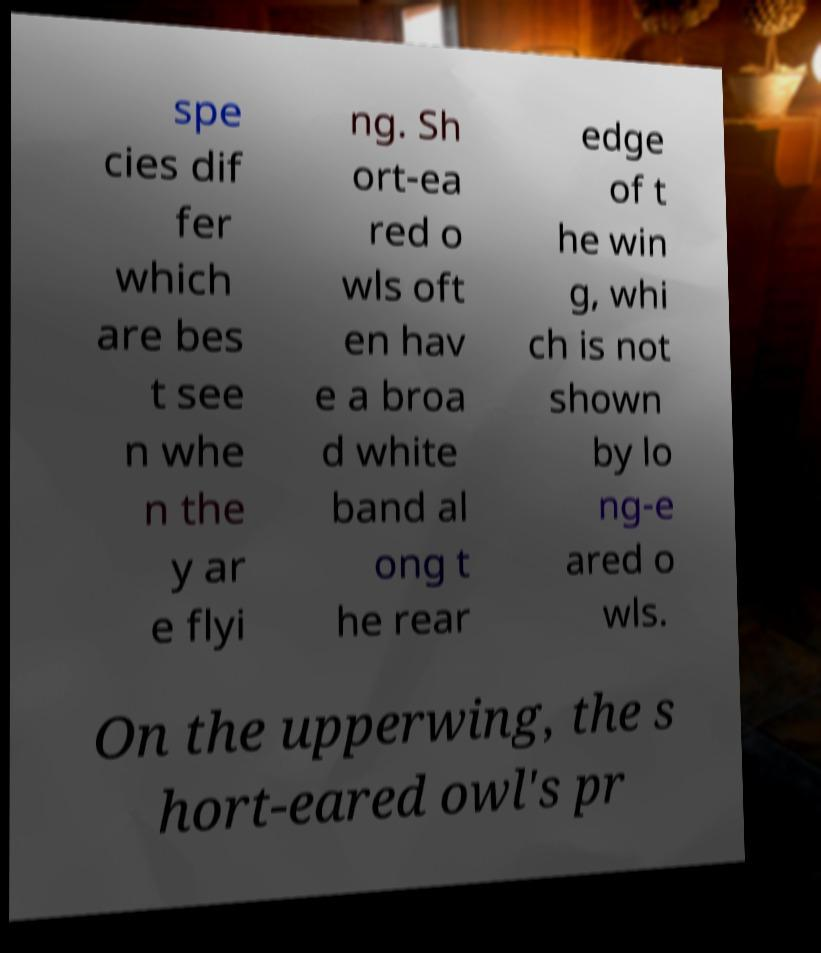Please read and relay the text visible in this image. What does it say? spe cies dif fer which are bes t see n whe n the y ar e flyi ng. Sh ort-ea red o wls oft en hav e a broa d white band al ong t he rear edge of t he win g, whi ch is not shown by lo ng-e ared o wls. On the upperwing, the s hort-eared owl's pr 